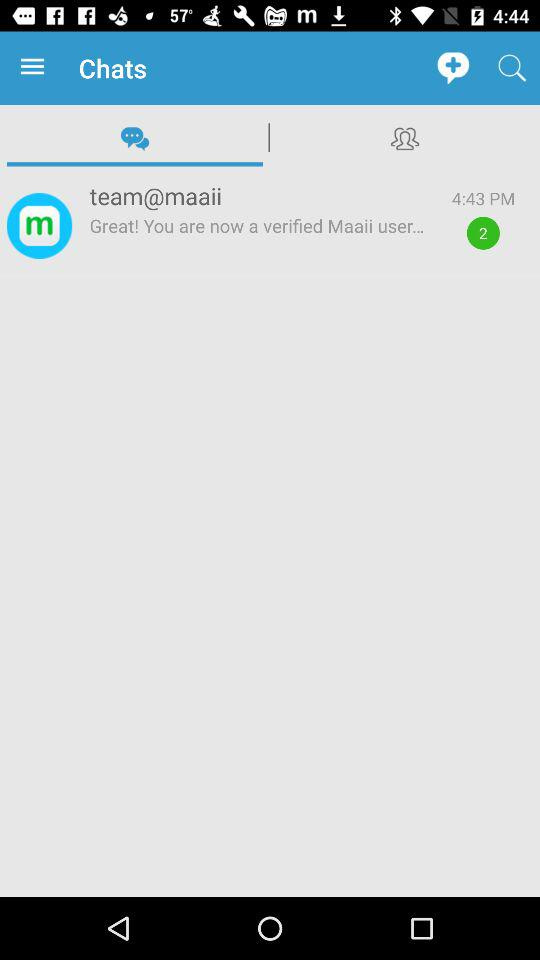What is the email address?
When the provided information is insufficient, respond with <no answer>. <no answer> 